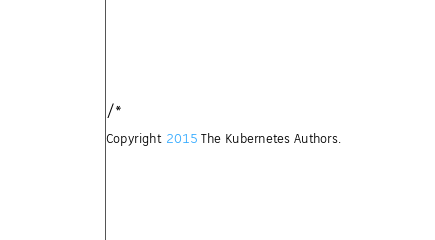Convert code to text. <code><loc_0><loc_0><loc_500><loc_500><_Go_>/*
Copyright 2015 The Kubernetes Authors.
</code> 